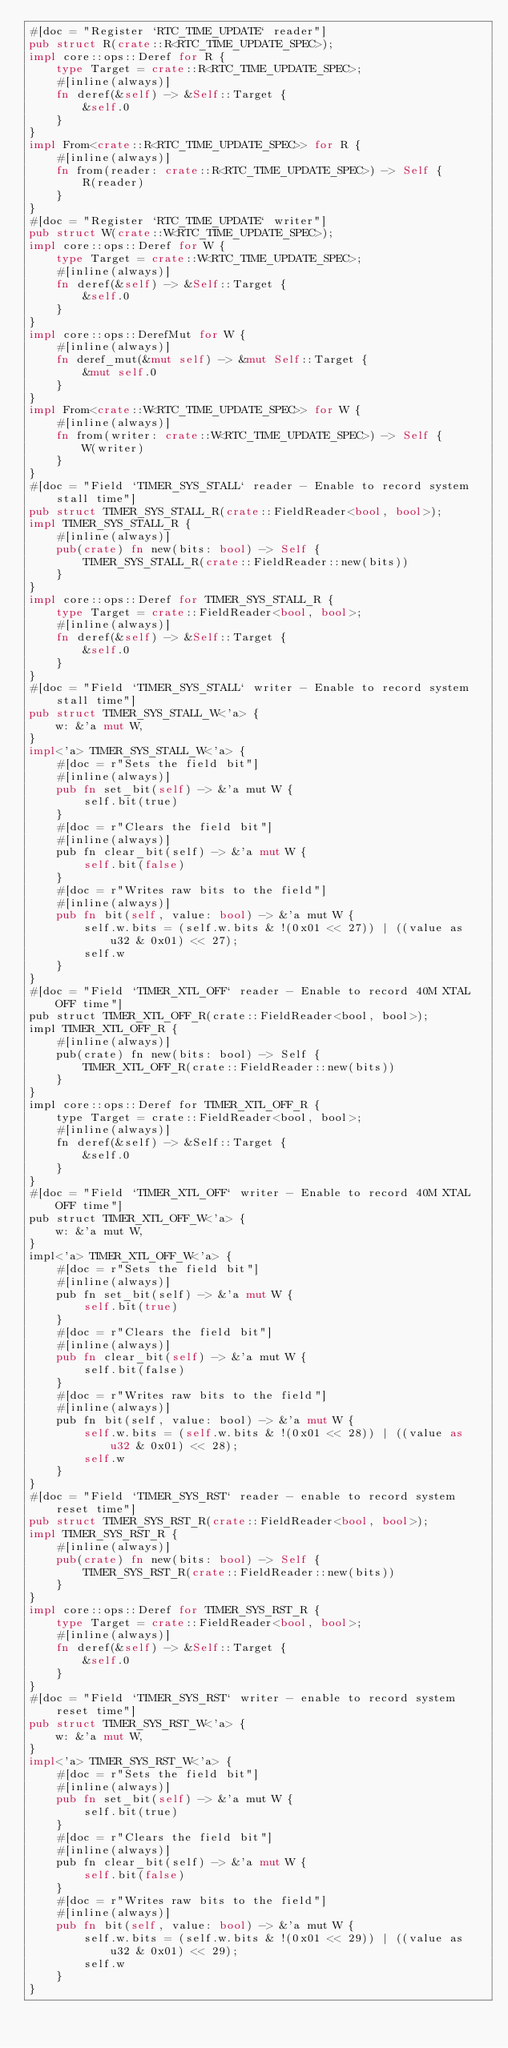Convert code to text. <code><loc_0><loc_0><loc_500><loc_500><_Rust_>#[doc = "Register `RTC_TIME_UPDATE` reader"]
pub struct R(crate::R<RTC_TIME_UPDATE_SPEC>);
impl core::ops::Deref for R {
    type Target = crate::R<RTC_TIME_UPDATE_SPEC>;
    #[inline(always)]
    fn deref(&self) -> &Self::Target {
        &self.0
    }
}
impl From<crate::R<RTC_TIME_UPDATE_SPEC>> for R {
    #[inline(always)]
    fn from(reader: crate::R<RTC_TIME_UPDATE_SPEC>) -> Self {
        R(reader)
    }
}
#[doc = "Register `RTC_TIME_UPDATE` writer"]
pub struct W(crate::W<RTC_TIME_UPDATE_SPEC>);
impl core::ops::Deref for W {
    type Target = crate::W<RTC_TIME_UPDATE_SPEC>;
    #[inline(always)]
    fn deref(&self) -> &Self::Target {
        &self.0
    }
}
impl core::ops::DerefMut for W {
    #[inline(always)]
    fn deref_mut(&mut self) -> &mut Self::Target {
        &mut self.0
    }
}
impl From<crate::W<RTC_TIME_UPDATE_SPEC>> for W {
    #[inline(always)]
    fn from(writer: crate::W<RTC_TIME_UPDATE_SPEC>) -> Self {
        W(writer)
    }
}
#[doc = "Field `TIMER_SYS_STALL` reader - Enable to record system stall time"]
pub struct TIMER_SYS_STALL_R(crate::FieldReader<bool, bool>);
impl TIMER_SYS_STALL_R {
    #[inline(always)]
    pub(crate) fn new(bits: bool) -> Self {
        TIMER_SYS_STALL_R(crate::FieldReader::new(bits))
    }
}
impl core::ops::Deref for TIMER_SYS_STALL_R {
    type Target = crate::FieldReader<bool, bool>;
    #[inline(always)]
    fn deref(&self) -> &Self::Target {
        &self.0
    }
}
#[doc = "Field `TIMER_SYS_STALL` writer - Enable to record system stall time"]
pub struct TIMER_SYS_STALL_W<'a> {
    w: &'a mut W,
}
impl<'a> TIMER_SYS_STALL_W<'a> {
    #[doc = r"Sets the field bit"]
    #[inline(always)]
    pub fn set_bit(self) -> &'a mut W {
        self.bit(true)
    }
    #[doc = r"Clears the field bit"]
    #[inline(always)]
    pub fn clear_bit(self) -> &'a mut W {
        self.bit(false)
    }
    #[doc = r"Writes raw bits to the field"]
    #[inline(always)]
    pub fn bit(self, value: bool) -> &'a mut W {
        self.w.bits = (self.w.bits & !(0x01 << 27)) | ((value as u32 & 0x01) << 27);
        self.w
    }
}
#[doc = "Field `TIMER_XTL_OFF` reader - Enable to record 40M XTAL OFF time"]
pub struct TIMER_XTL_OFF_R(crate::FieldReader<bool, bool>);
impl TIMER_XTL_OFF_R {
    #[inline(always)]
    pub(crate) fn new(bits: bool) -> Self {
        TIMER_XTL_OFF_R(crate::FieldReader::new(bits))
    }
}
impl core::ops::Deref for TIMER_XTL_OFF_R {
    type Target = crate::FieldReader<bool, bool>;
    #[inline(always)]
    fn deref(&self) -> &Self::Target {
        &self.0
    }
}
#[doc = "Field `TIMER_XTL_OFF` writer - Enable to record 40M XTAL OFF time"]
pub struct TIMER_XTL_OFF_W<'a> {
    w: &'a mut W,
}
impl<'a> TIMER_XTL_OFF_W<'a> {
    #[doc = r"Sets the field bit"]
    #[inline(always)]
    pub fn set_bit(self) -> &'a mut W {
        self.bit(true)
    }
    #[doc = r"Clears the field bit"]
    #[inline(always)]
    pub fn clear_bit(self) -> &'a mut W {
        self.bit(false)
    }
    #[doc = r"Writes raw bits to the field"]
    #[inline(always)]
    pub fn bit(self, value: bool) -> &'a mut W {
        self.w.bits = (self.w.bits & !(0x01 << 28)) | ((value as u32 & 0x01) << 28);
        self.w
    }
}
#[doc = "Field `TIMER_SYS_RST` reader - enable to record system reset time"]
pub struct TIMER_SYS_RST_R(crate::FieldReader<bool, bool>);
impl TIMER_SYS_RST_R {
    #[inline(always)]
    pub(crate) fn new(bits: bool) -> Self {
        TIMER_SYS_RST_R(crate::FieldReader::new(bits))
    }
}
impl core::ops::Deref for TIMER_SYS_RST_R {
    type Target = crate::FieldReader<bool, bool>;
    #[inline(always)]
    fn deref(&self) -> &Self::Target {
        &self.0
    }
}
#[doc = "Field `TIMER_SYS_RST` writer - enable to record system reset time"]
pub struct TIMER_SYS_RST_W<'a> {
    w: &'a mut W,
}
impl<'a> TIMER_SYS_RST_W<'a> {
    #[doc = r"Sets the field bit"]
    #[inline(always)]
    pub fn set_bit(self) -> &'a mut W {
        self.bit(true)
    }
    #[doc = r"Clears the field bit"]
    #[inline(always)]
    pub fn clear_bit(self) -> &'a mut W {
        self.bit(false)
    }
    #[doc = r"Writes raw bits to the field"]
    #[inline(always)]
    pub fn bit(self, value: bool) -> &'a mut W {
        self.w.bits = (self.w.bits & !(0x01 << 29)) | ((value as u32 & 0x01) << 29);
        self.w
    }
}</code> 